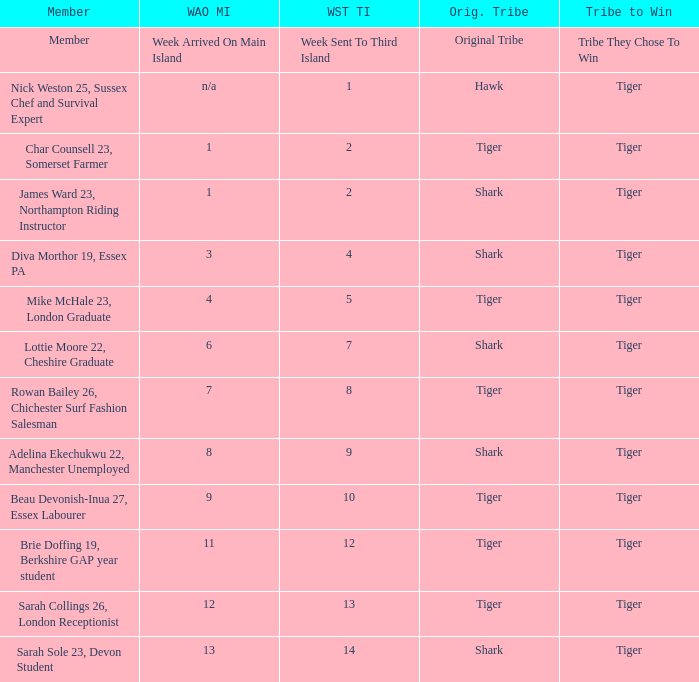What week was the member who arrived on the main island in week 6 sent to the third island? 7.0. 